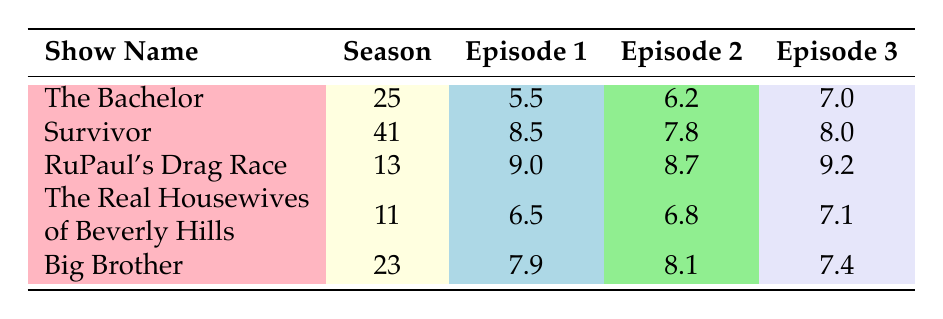What is the rating of Episode 2 of "The Bachelor"? According to the table, the rating for Episode 2 of "The Bachelor" is directly listed as 6.2.
Answer: 6.2 What is the highest-rated Episode 1 across all shows? By checking the ratings listed under each show's Episode 1, "RuPaul's Drag Race" has the highest rating of 9.0.
Answer: 9.0 Is the rating of Episode 3 in "Big Brother" higher than that of Episode 1 in "Survivor"? The rating for Episode 3 in "Big Brother" is 7.4, while Episode 1 in "Survivor" has a rating of 8.5. Since 7.4 is less than 8.5, the statement is false.
Answer: No What is the average rating of Episode 1 across all listed shows? The ratings for Episode 1 are: The Bachelor (5.5), Survivor (8.5), RuPaul's Drag Race (9.0), The Real Housewives of Beverly Hills (6.5), and Big Brother (7.9). Summing these gives 37.4, and dividing by 5 results in an average of 7.48.
Answer: 7.48 Was the average rating of Episode 2 across all listed shows above 7? The ratings for Episode 2 are: The Bachelor (6.2), Survivor (7.8), RuPaul's Drag Race (8.7), The Real Housewives of Beverly Hills (6.8), and Big Brother (8.1). Summing these gives 37.6, which divided by 5 results in an average of 7.52, confirming that it is above 7.
Answer: Yes Which show has the lowest rating for Episode 3? Referencing Episode 3 ratings: The Bachelor (7.0), Survivor (8.0), RuPaul's Drag Race (9.2), The Real Housewives of Beverly Hills (7.1), and Big Brother (7.4), the lowest is 7.0 for "The Bachelor".
Answer: The Bachelor What is the difference in rating between Episode 1 and Episode 2 for "RuPaul's Drag Race"? The rating for Episode 1 is 9.0, and for Episode 2 it is 8.7. The difference is calculated as 9.0 - 8.7 = 0.3.
Answer: 0.3 Are all the ratings for "The Real Housewives of Beverly Hills" below 8? The ratings listed for "The Real Housewives of Beverly Hills" are 6.5, 6.8, and 7.1. Since none of these are 8 or above, the statement is true.
Answer: Yes 